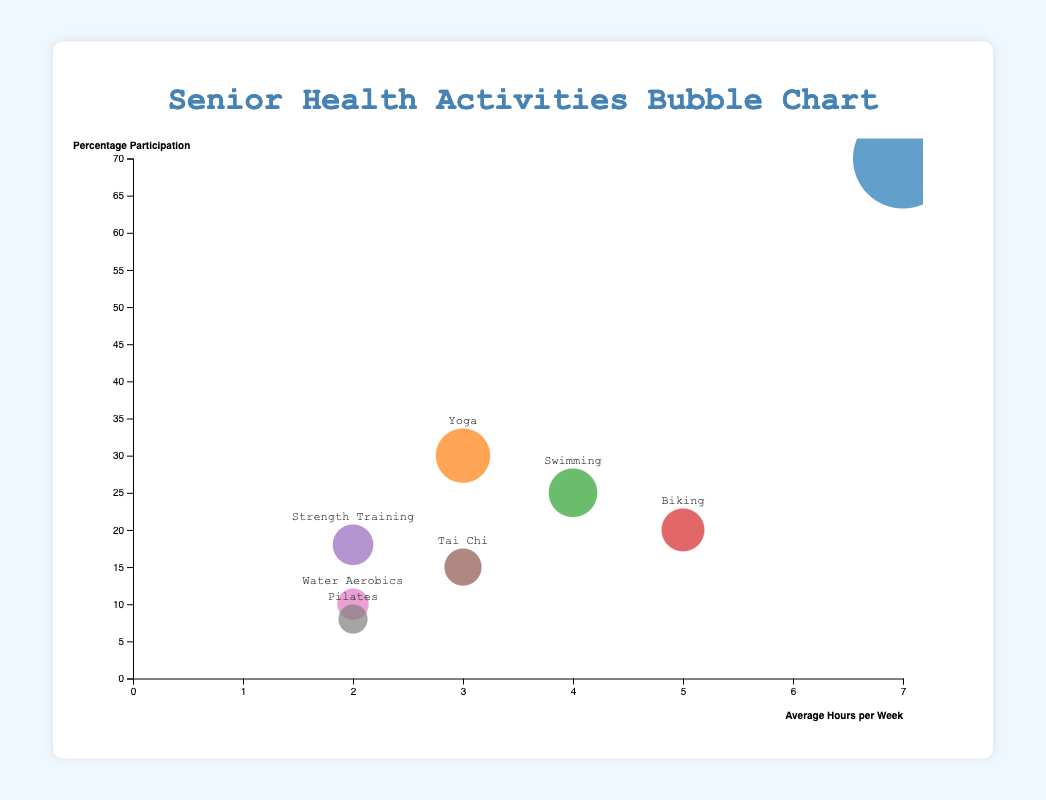Which activity has the highest participation percentage and how many average hours per week do participants engage in it? The activity with the highest participation percentage has the largest vertical position. Look for the highest point on the y-axis which belongs to "Walking," and check its corresponding average hours per week on the x-axis. Walking has 70% participation with 7 average hours per week.
Answer: Walking, 7 hours How does Yoga compare to Biking in terms of average hours per week and percentage participation? Compare the x-axis and y-axis coordinates of Yoga and Biking. Yoga has 3 average hours per week and 30% participation, while Biking has 5 average hours per week and 20% participation. Yoga has fewer hours per week but a higher participation percentage than Biking.
Answer: Yoga: 3 hours, 30%; Biking: 5 hours, 20% Which activity has the most number of participants and how many are they? The size of the bubbles represents the number of participants. The largest bubble corresponds to "Walking," which has 140 participants.
Answer: Walking, 140 participants What is the average number of hours spent per week on Water Aerobics and Strength Training combined? Identify the average hours per week for each activity and sum them up. Water Aerobics (2 hours) + Strength Training (2 hours) = 4 hours.
Answer: 4 hours Which activity has a lower percentage participation, Pilates or Tai Chi, and by how much? Compare the y-axis positions of Pilates and Tai Chi. Pilates has 8% participation, while Tai Chi has 15%. The difference is 15% - 8% = 7%.
Answer: Pilates, 7% What’s the total number of participants for the activities with less than 20% participation? Sum the number of participants for activities with less than 20% participation (Strength Training, Tai Chi, Water Aerobics, Pilates). Strength Training (36) + Tai Chi (30) + Water Aerobics (20) + Pilates (16) = 102 participants.
Answer: 102 participants Which activities occupy the top three positions by the number of participants? Order the activities by bubble size and identify the top three. The largest three are Walking (140), Yoga (60), and Swimming (50).
Answer: Walking, Yoga, Swimming 